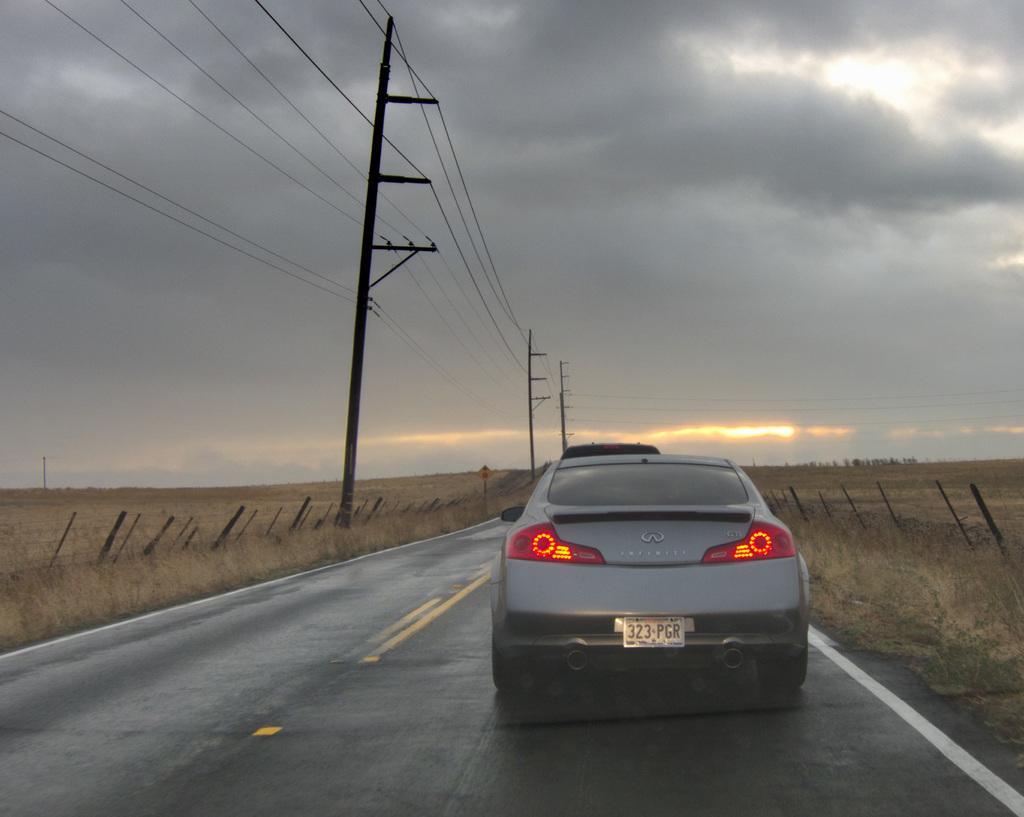In one or two sentences, can you explain what this image depicts? In this picture we can see a car on the road, grass, poles, wires and board. In the background of the image we can see the sky with clouds. 